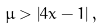<formula> <loc_0><loc_0><loc_500><loc_500>\mu > \left | 4 x - 1 \right | ,</formula> 